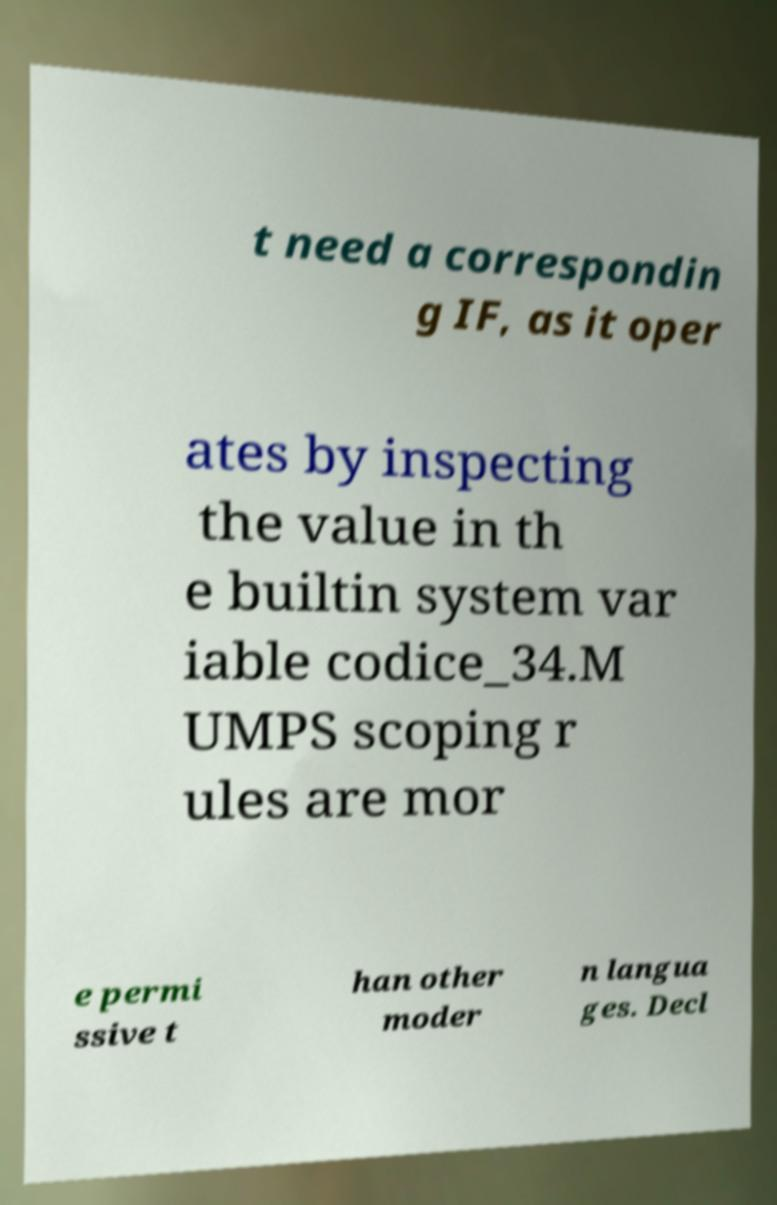Could you assist in decoding the text presented in this image and type it out clearly? t need a correspondin g IF, as it oper ates by inspecting the value in th e builtin system var iable codice_34.M UMPS scoping r ules are mor e permi ssive t han other moder n langua ges. Decl 